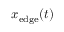Convert formula to latex. <formula><loc_0><loc_0><loc_500><loc_500>x _ { e d g e } ( t )</formula> 